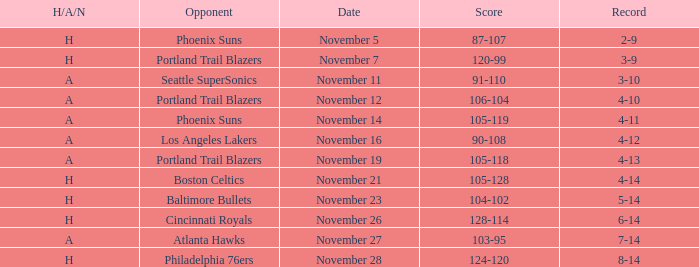What is the Opponent of the game with a H/A/N of H and Score of 120-99? Portland Trail Blazers. 